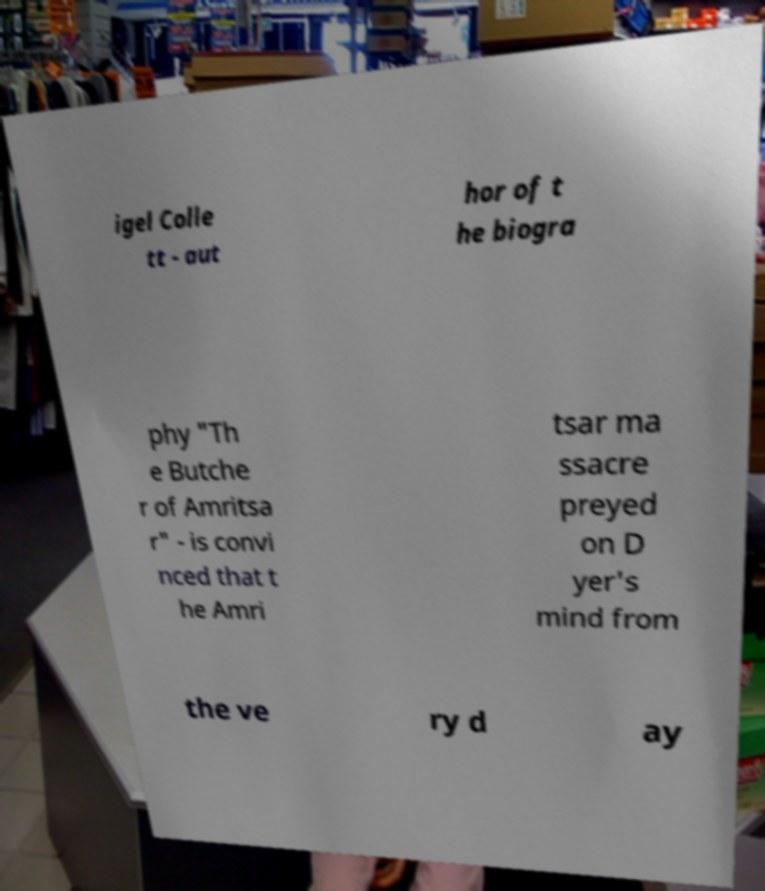What messages or text are displayed in this image? I need them in a readable, typed format. igel Colle tt - aut hor of t he biogra phy "Th e Butche r of Amritsa r" - is convi nced that t he Amri tsar ma ssacre preyed on D yer's mind from the ve ry d ay 